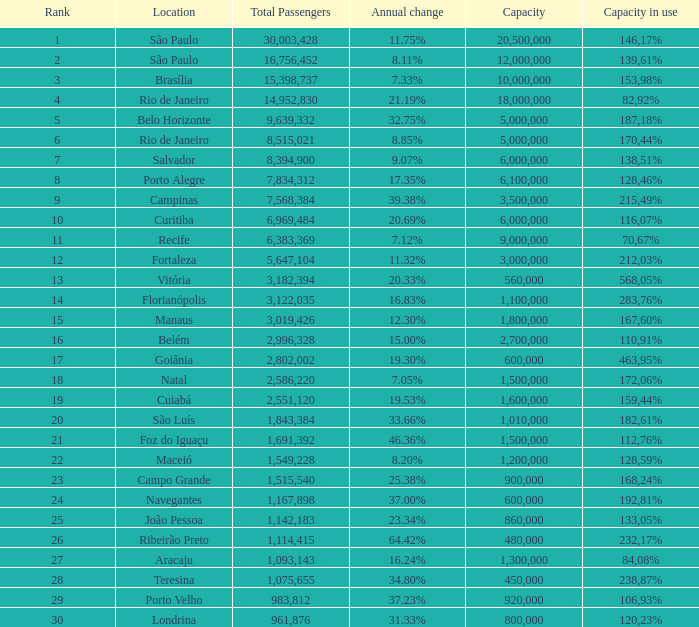60%? 1800000.0. 